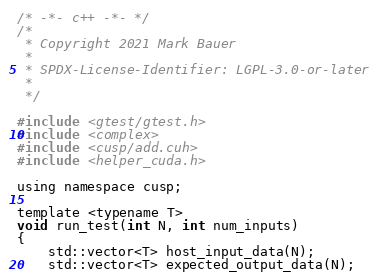<code> <loc_0><loc_0><loc_500><loc_500><_Cuda_>/* -*- c++ -*- */
/*
 * Copyright 2021 Mark Bauer
 *
 * SPDX-License-Identifier: LGPL-3.0-or-later
 *
 */

#include <gtest/gtest.h>
#include <complex>
#include <cusp/add.cuh>
#include <helper_cuda.h>

using namespace cusp;

template <typename T> 
void run_test(int N, int num_inputs)
{
    std::vector<T> host_input_data(N);
    std::vector<T> expected_output_data(N);</code> 